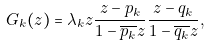Convert formula to latex. <formula><loc_0><loc_0><loc_500><loc_500>G _ { k } ( z ) = \lambda _ { k } z \frac { z - p _ { k } } { 1 - \overline { p _ { k } } z } \frac { z - q _ { k } } { 1 - \overline { q _ { k } } z } ,</formula> 